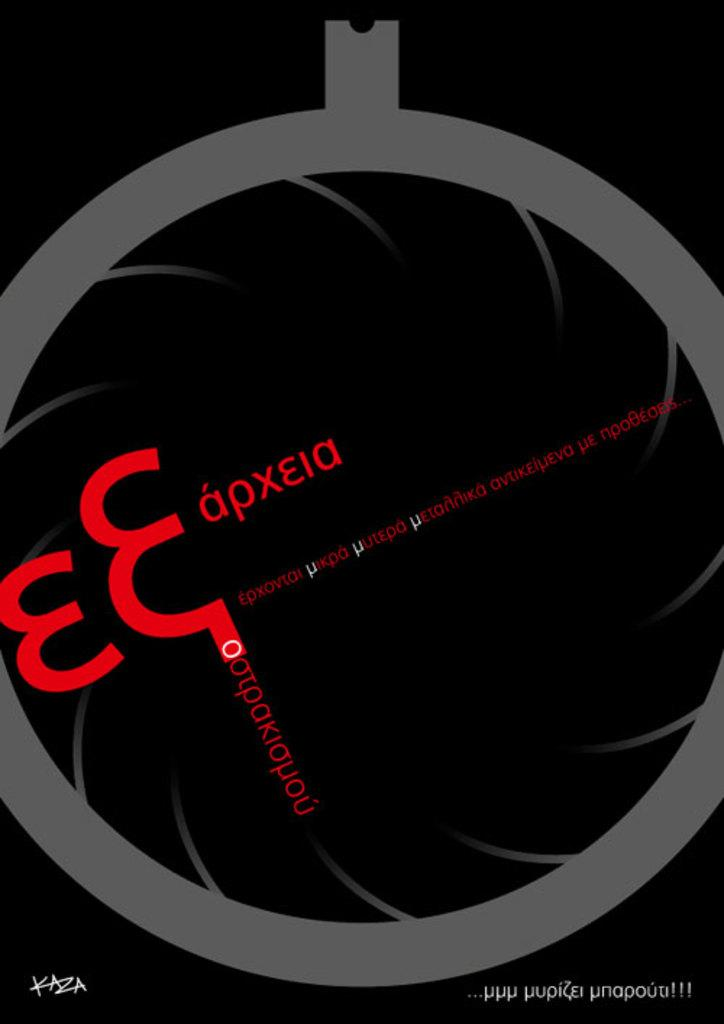Provide a one-sentence caption for the provided image. Foreign language E Eapxeia product in red lettering on a black and gray background. 